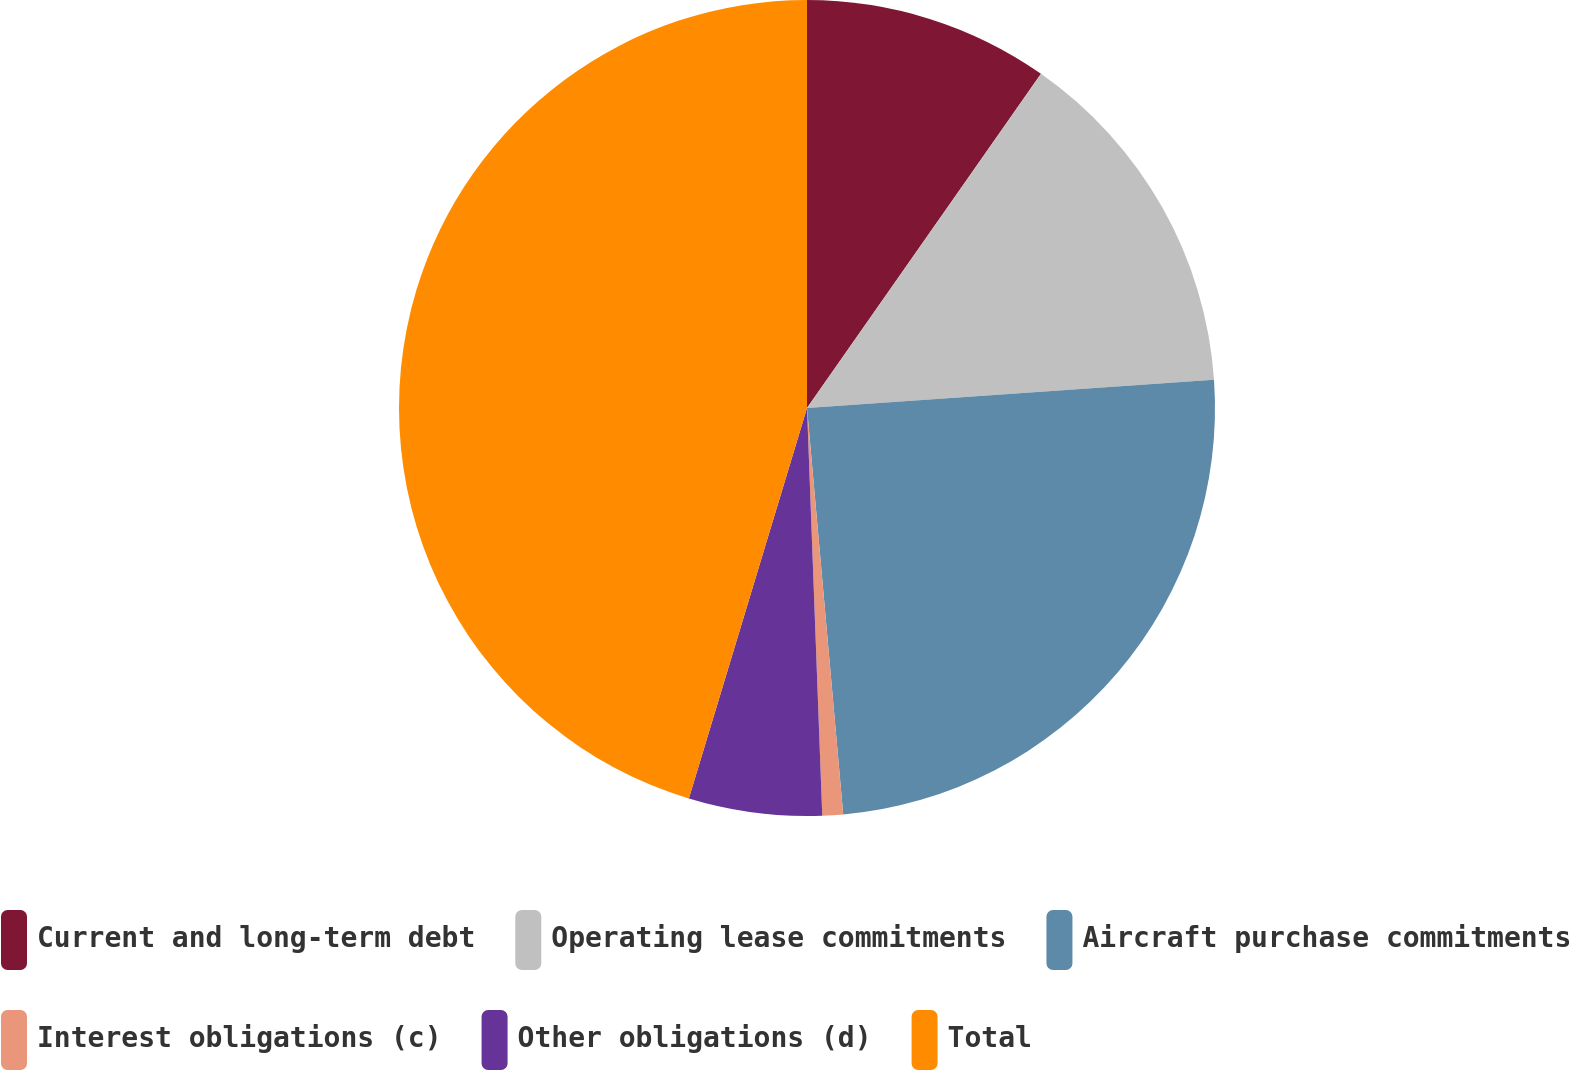<chart> <loc_0><loc_0><loc_500><loc_500><pie_chart><fcel>Current and long-term debt<fcel>Operating lease commitments<fcel>Aircraft purchase commitments<fcel>Interest obligations (c)<fcel>Other obligations (d)<fcel>Total<nl><fcel>9.72%<fcel>14.17%<fcel>24.69%<fcel>0.82%<fcel>5.27%<fcel>45.32%<nl></chart> 